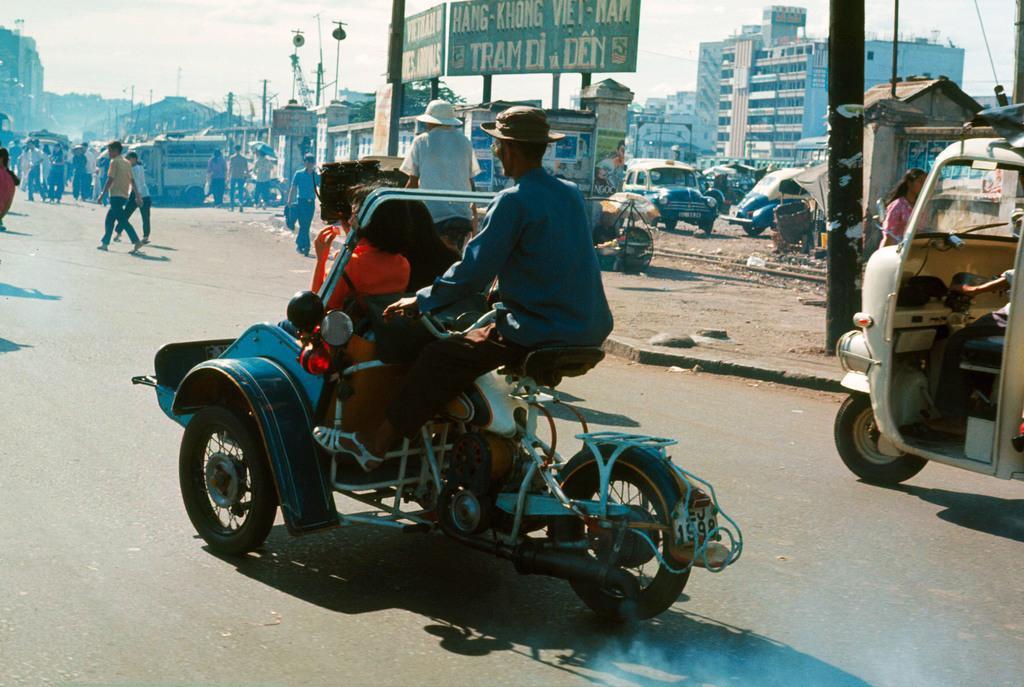Please provide a concise description of this image. A person wearing a hat is sitting on a vehicle. On the vehicle there are many bags. There is a road. Also some other vehicles on the road. In the background there are buildings, pillars, name boards, persons, vehicles. 